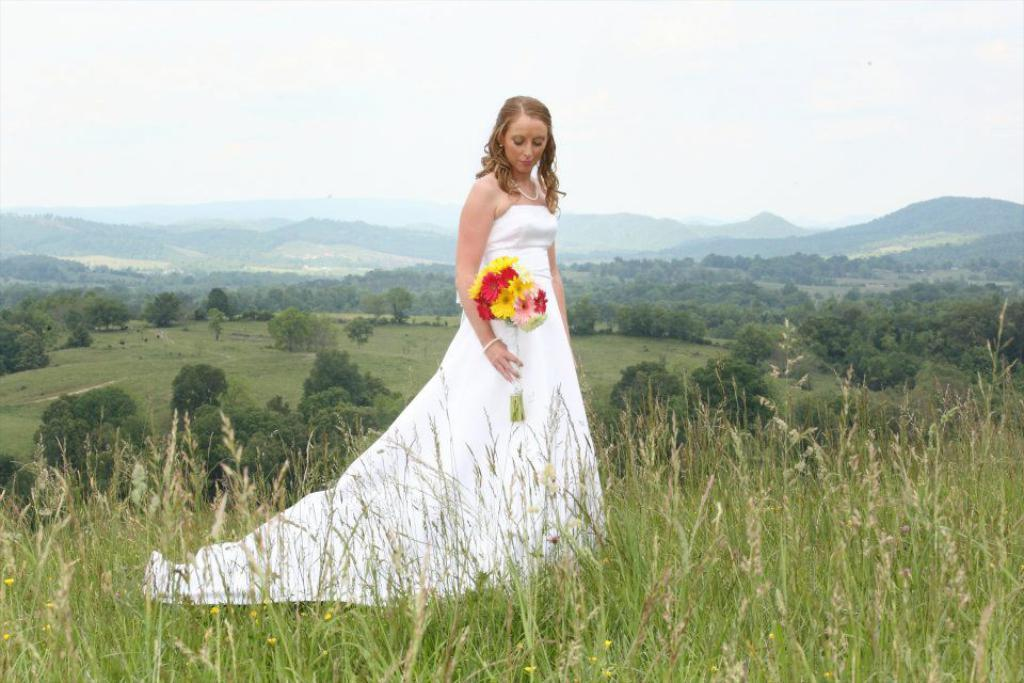What is the person in the image doing? The person is standing in the image and holding colorful flowers. What is the person wearing? The person is wearing a white dress. What can be seen in the background of the image? There are trees, mountains, grass, and the sky visible in the image. What type of calculator is the person using in the image? There is no calculator present in the image. How many fingers does the person have on their left hand in the image? The image does not provide enough detail to determine the number of fingers on the person's left hand. 